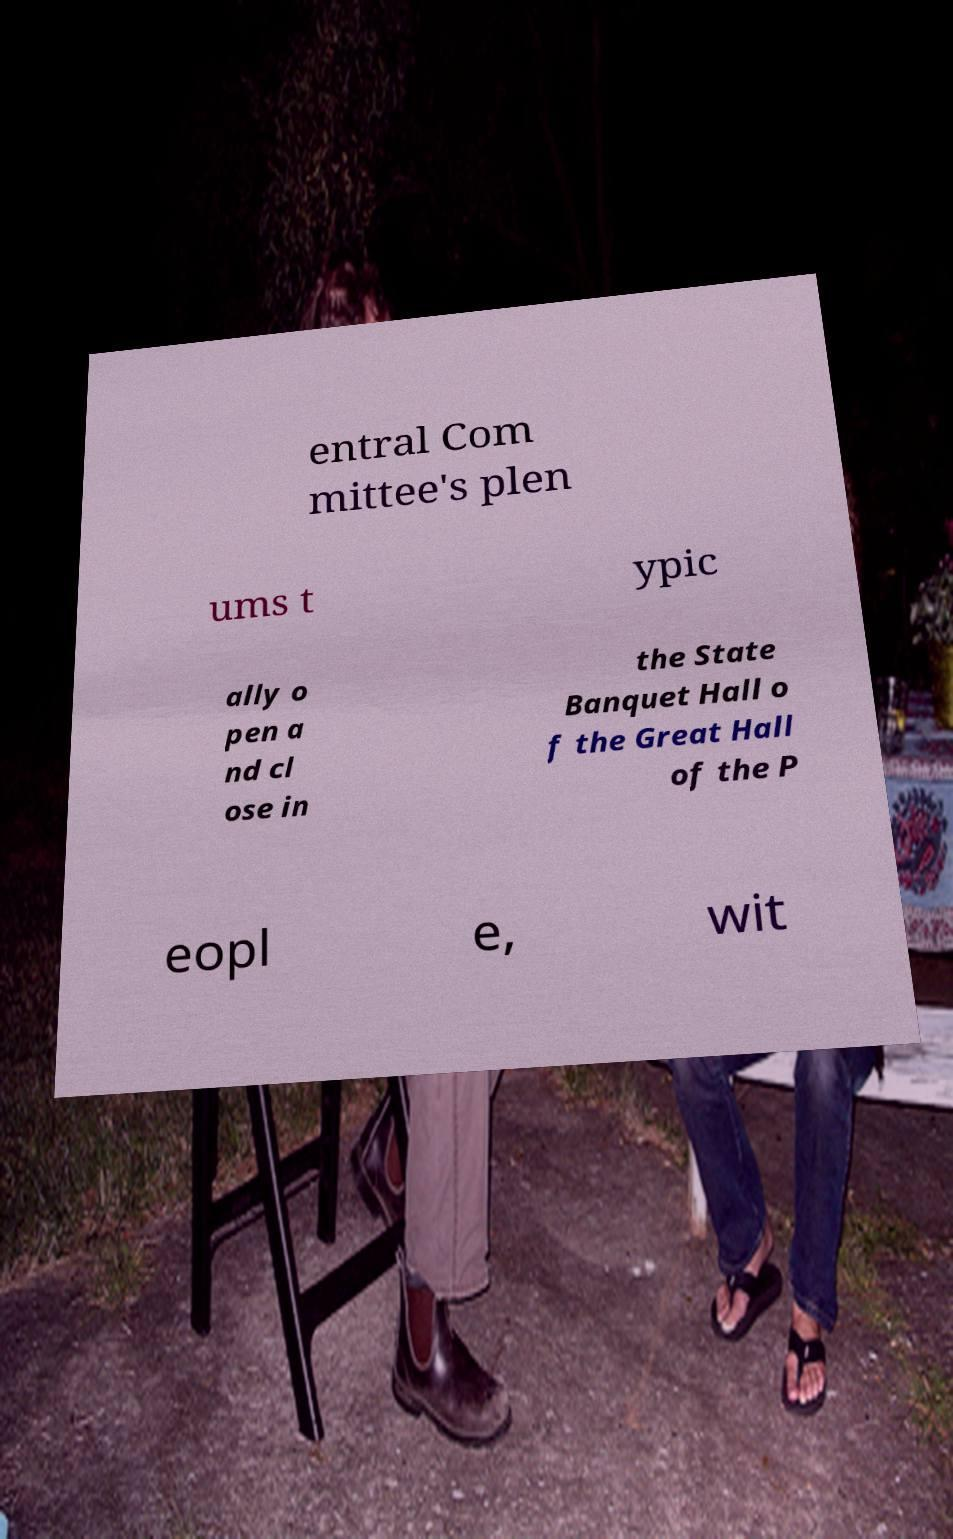Could you assist in decoding the text presented in this image and type it out clearly? entral Com mittee's plen ums t ypic ally o pen a nd cl ose in the State Banquet Hall o f the Great Hall of the P eopl e, wit 